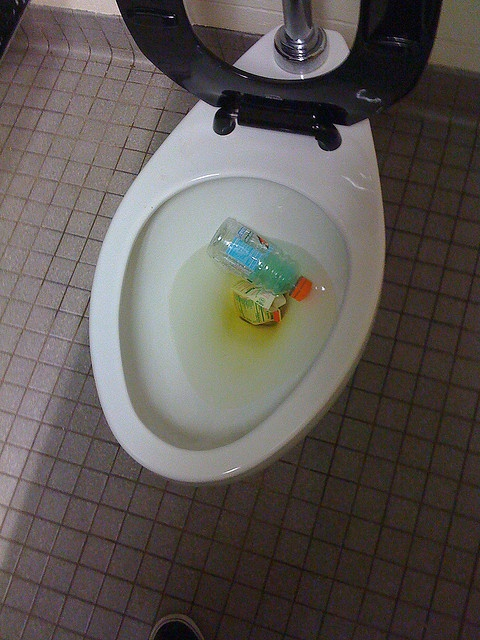Describe the objects in this image and their specific colors. I can see toilet in black, darkgray, and gray tones and bottle in black, teal, and darkgray tones in this image. 